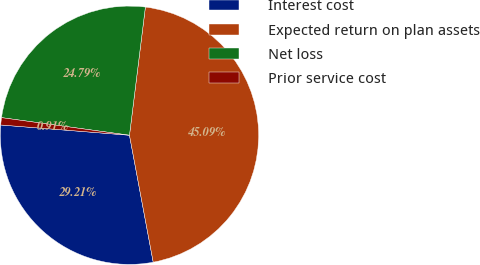Convert chart to OTSL. <chart><loc_0><loc_0><loc_500><loc_500><pie_chart><fcel>Interest cost<fcel>Expected return on plan assets<fcel>Net loss<fcel>Prior service cost<nl><fcel>29.21%<fcel>45.09%<fcel>24.79%<fcel>0.91%<nl></chart> 